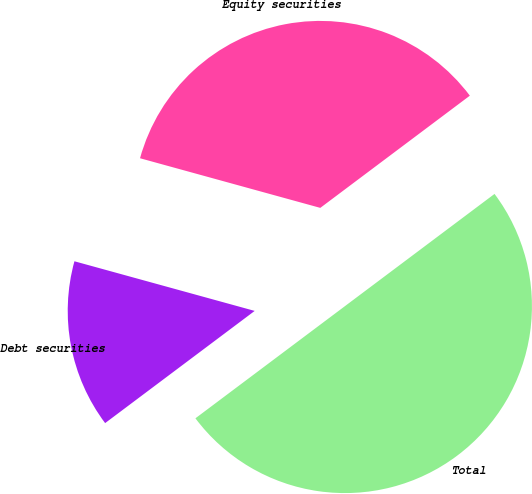Convert chart. <chart><loc_0><loc_0><loc_500><loc_500><pie_chart><fcel>Equity securities<fcel>Debt securities<fcel>Total<nl><fcel>35.48%<fcel>14.52%<fcel>50.0%<nl></chart> 